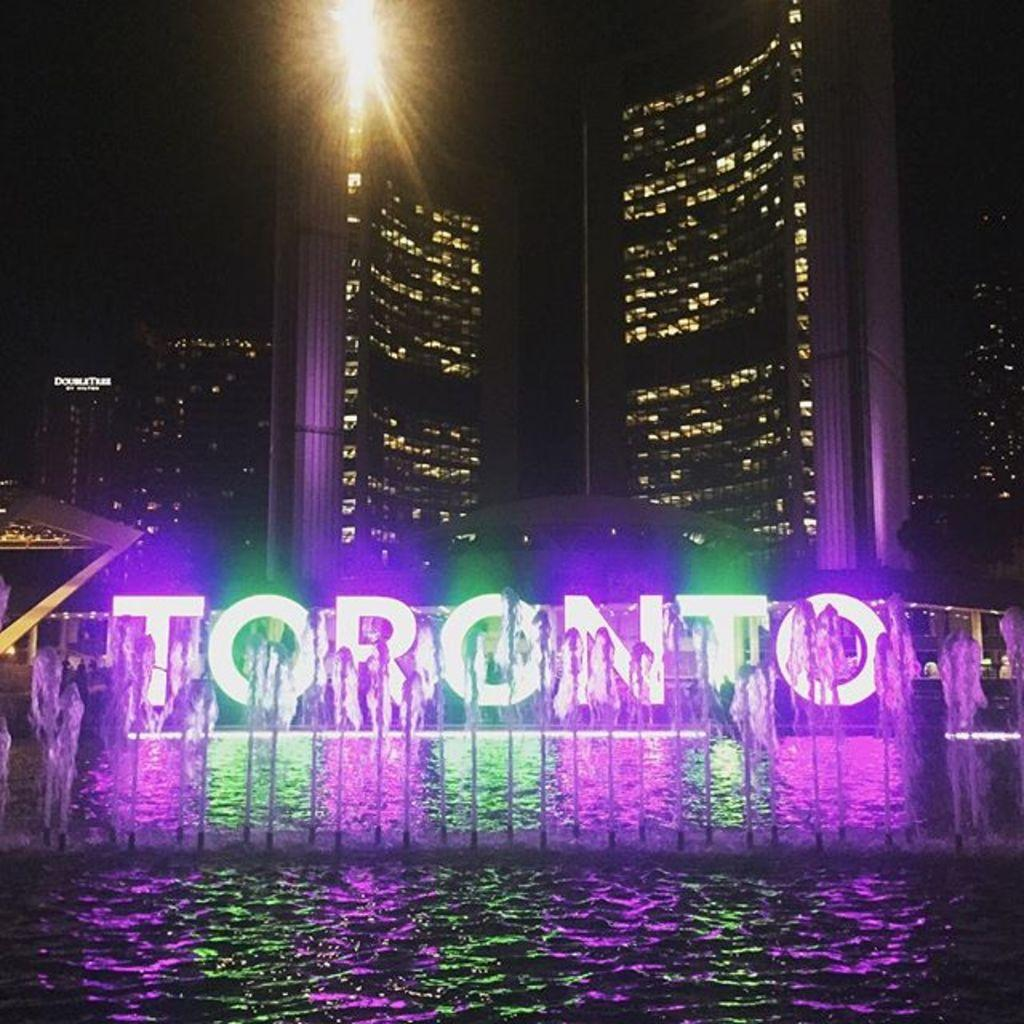What is the primary element in the image? The image consists of water. What can be seen in the middle of the water? There is a fountain in the middle of the water. What is visible in the background of the image? There is a building and lights in the background of the image. How would you describe the lighting conditions in the image? The image appears to be taken in low light or darkness. What is the chance of harmony being achieved in the image? There is no reference to harmony or any chance of achieving it in the image, as it features water, a fountain, and a background with a building and lights. 